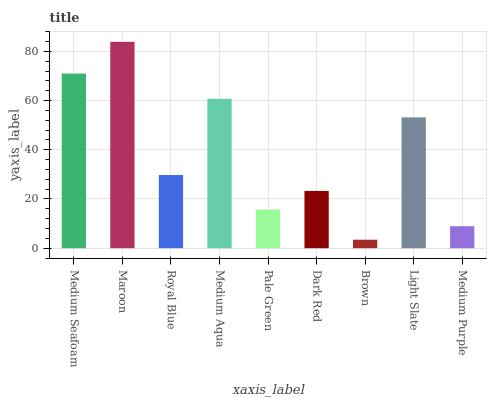Is Brown the minimum?
Answer yes or no. Yes. Is Maroon the maximum?
Answer yes or no. Yes. Is Royal Blue the minimum?
Answer yes or no. No. Is Royal Blue the maximum?
Answer yes or no. No. Is Maroon greater than Royal Blue?
Answer yes or no. Yes. Is Royal Blue less than Maroon?
Answer yes or no. Yes. Is Royal Blue greater than Maroon?
Answer yes or no. No. Is Maroon less than Royal Blue?
Answer yes or no. No. Is Royal Blue the high median?
Answer yes or no. Yes. Is Royal Blue the low median?
Answer yes or no. Yes. Is Medium Purple the high median?
Answer yes or no. No. Is Brown the low median?
Answer yes or no. No. 